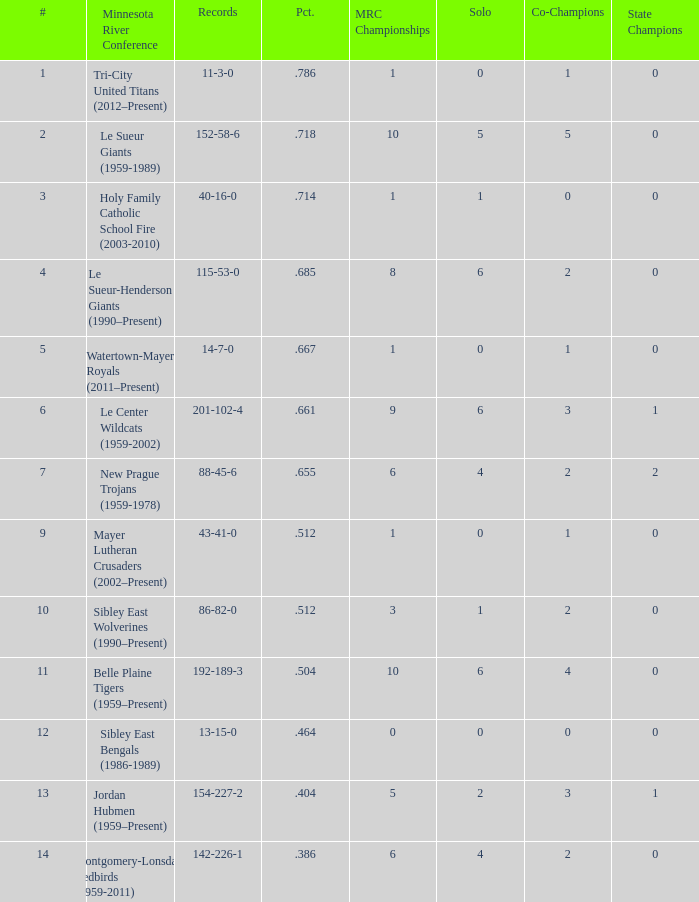What are the record(s) for the team with a winning percentage of .464? 13-15-0. 